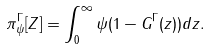<formula> <loc_0><loc_0><loc_500><loc_500>\pi _ { \psi } ^ { \Gamma } [ Z ] = \int _ { 0 } ^ { \infty } \psi ( 1 - G ^ { \Gamma } ( z ) ) d z .</formula> 